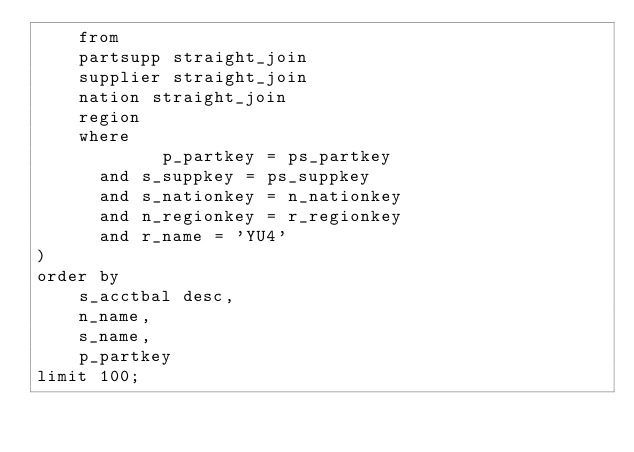Convert code to text. <code><loc_0><loc_0><loc_500><loc_500><_SQL_>    from
    partsupp straight_join
    supplier straight_join
    nation straight_join
    region
    where
            p_partkey = ps_partkey
      and s_suppkey = ps_suppkey
      and s_nationkey = n_nationkey
      and n_regionkey = r_regionkey
      and r_name = 'YU4'
)
order by
    s_acctbal desc,
    n_name,
    s_name,
    p_partkey
limit 100;
</code> 